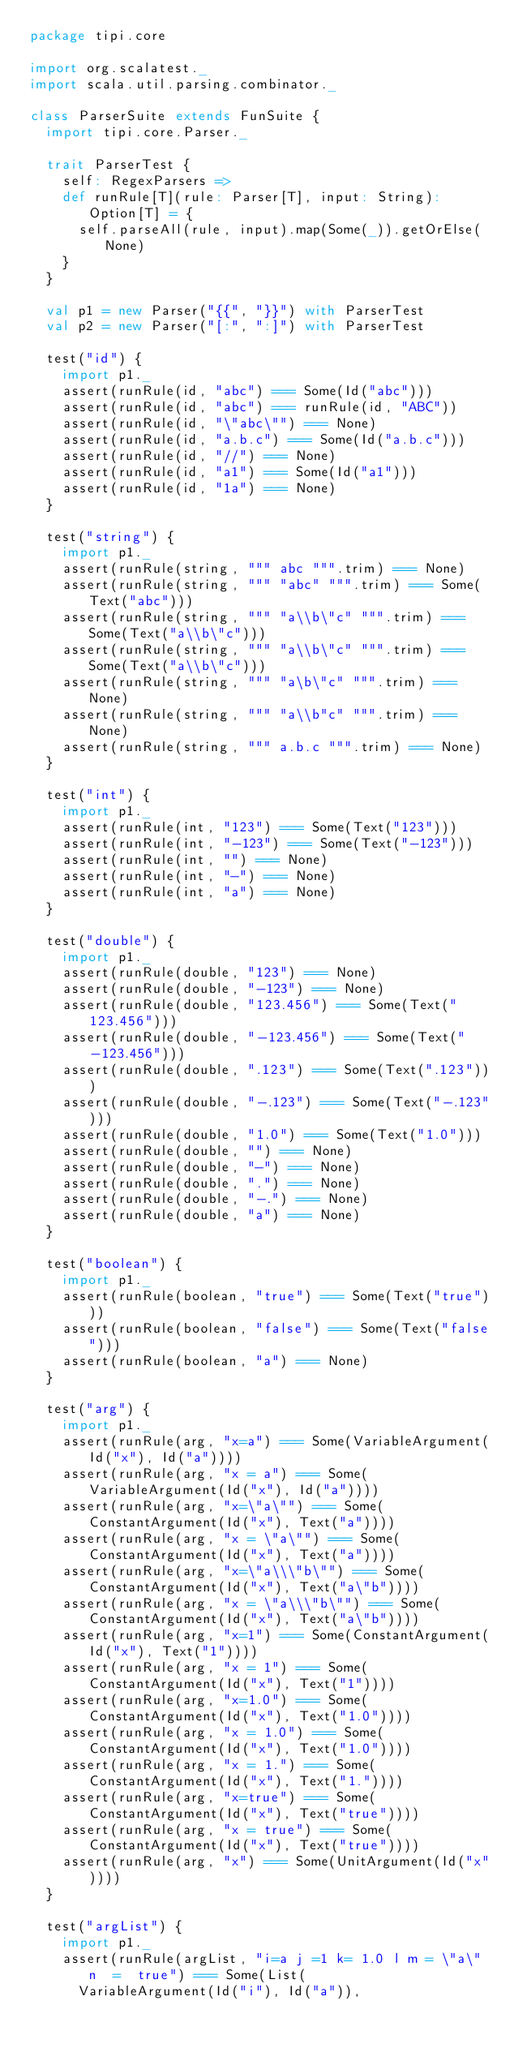<code> <loc_0><loc_0><loc_500><loc_500><_Scala_>package tipi.core

import org.scalatest._
import scala.util.parsing.combinator._

class ParserSuite extends FunSuite {
  import tipi.core.Parser._

  trait ParserTest {
    self: RegexParsers =>
    def runRule[T](rule: Parser[T], input: String): Option[T] = {
      self.parseAll(rule, input).map(Some(_)).getOrElse(None)
    }
  }

  val p1 = new Parser("{{", "}}") with ParserTest
  val p2 = new Parser("[:", ":]") with ParserTest

  test("id") {
    import p1._
    assert(runRule(id, "abc") === Some(Id("abc")))
    assert(runRule(id, "abc") === runRule(id, "ABC"))
    assert(runRule(id, "\"abc\"") === None)
    assert(runRule(id, "a.b.c") === Some(Id("a.b.c")))
    assert(runRule(id, "//") === None)
    assert(runRule(id, "a1") === Some(Id("a1")))
    assert(runRule(id, "1a") === None)
  }

  test("string") {
    import p1._
    assert(runRule(string, """ abc """.trim) === None)
    assert(runRule(string, """ "abc" """.trim) === Some(Text("abc")))
    assert(runRule(string, """ "a\\b\"c" """.trim) === Some(Text("a\\b\"c")))
    assert(runRule(string, """ "a\\b\"c" """.trim) === Some(Text("a\\b\"c")))
    assert(runRule(string, """ "a\b\"c" """.trim) === None)
    assert(runRule(string, """ "a\\b"c" """.trim) === None)
    assert(runRule(string, """ a.b.c """.trim) === None)
  }

  test("int") {
    import p1._
    assert(runRule(int, "123") === Some(Text("123")))
    assert(runRule(int, "-123") === Some(Text("-123")))
    assert(runRule(int, "") === None)
    assert(runRule(int, "-") === None)
    assert(runRule(int, "a") === None)
  }

  test("double") {
    import p1._
    assert(runRule(double, "123") === None)
    assert(runRule(double, "-123") === None)
    assert(runRule(double, "123.456") === Some(Text("123.456")))
    assert(runRule(double, "-123.456") === Some(Text("-123.456")))
    assert(runRule(double, ".123") === Some(Text(".123")))
    assert(runRule(double, "-.123") === Some(Text("-.123")))
    assert(runRule(double, "1.0") === Some(Text("1.0")))
    assert(runRule(double, "") === None)
    assert(runRule(double, "-") === None)
    assert(runRule(double, ".") === None)
    assert(runRule(double, "-.") === None)
    assert(runRule(double, "a") === None)
  }

  test("boolean") {
    import p1._
    assert(runRule(boolean, "true") === Some(Text("true")))
    assert(runRule(boolean, "false") === Some(Text("false")))
    assert(runRule(boolean, "a") === None)
  }

  test("arg") {
    import p1._
    assert(runRule(arg, "x=a") === Some(VariableArgument(Id("x"), Id("a"))))
    assert(runRule(arg, "x = a") === Some(VariableArgument(Id("x"), Id("a"))))
    assert(runRule(arg, "x=\"a\"") === Some(ConstantArgument(Id("x"), Text("a"))))
    assert(runRule(arg, "x = \"a\"") === Some(ConstantArgument(Id("x"), Text("a"))))
    assert(runRule(arg, "x=\"a\\\"b\"") === Some(ConstantArgument(Id("x"), Text("a\"b"))))
    assert(runRule(arg, "x = \"a\\\"b\"") === Some(ConstantArgument(Id("x"), Text("a\"b"))))
    assert(runRule(arg, "x=1") === Some(ConstantArgument(Id("x"), Text("1"))))
    assert(runRule(arg, "x = 1") === Some(ConstantArgument(Id("x"), Text("1"))))
    assert(runRule(arg, "x=1.0") === Some(ConstantArgument(Id("x"), Text("1.0"))))
    assert(runRule(arg, "x = 1.0") === Some(ConstantArgument(Id("x"), Text("1.0"))))
    assert(runRule(arg, "x = 1.") === Some(ConstantArgument(Id("x"), Text("1."))))
    assert(runRule(arg, "x=true") === Some(ConstantArgument(Id("x"), Text("true"))))
    assert(runRule(arg, "x = true") === Some(ConstantArgument(Id("x"), Text("true"))))
    assert(runRule(arg, "x") === Some(UnitArgument(Id("x"))))
  }

  test("argList") {
    import p1._
    assert(runRule(argList, "i=a j =1 k= 1.0 l m = \"a\" n  =  true") === Some(List(
      VariableArgument(Id("i"), Id("a")),</code> 